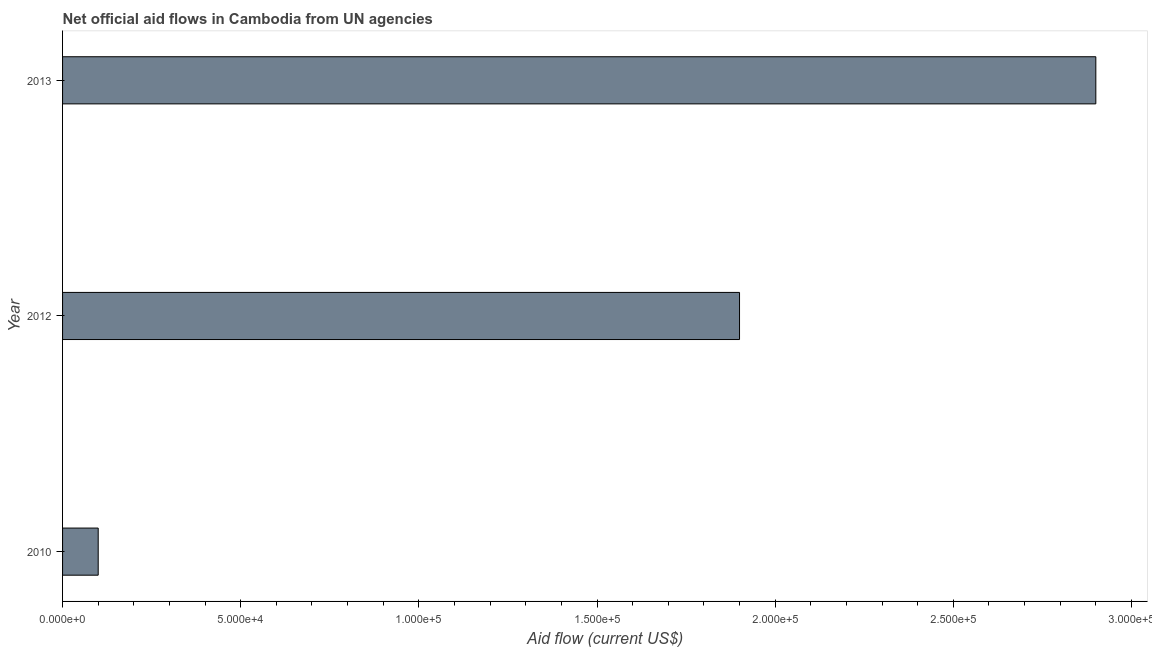Does the graph contain grids?
Make the answer very short. No. What is the title of the graph?
Provide a short and direct response. Net official aid flows in Cambodia from UN agencies. What is the label or title of the Y-axis?
Your response must be concise. Year. Across all years, what is the maximum net official flows from un agencies?
Your answer should be very brief. 2.90e+05. Across all years, what is the minimum net official flows from un agencies?
Your answer should be compact. 10000. In which year was the net official flows from un agencies maximum?
Your response must be concise. 2013. In which year was the net official flows from un agencies minimum?
Your answer should be very brief. 2010. What is the sum of the net official flows from un agencies?
Provide a succinct answer. 4.90e+05. What is the average net official flows from un agencies per year?
Offer a terse response. 1.63e+05. What is the ratio of the net official flows from un agencies in 2010 to that in 2012?
Your answer should be very brief. 0.05. Is the difference between the net official flows from un agencies in 2012 and 2013 greater than the difference between any two years?
Your response must be concise. No. Is the sum of the net official flows from un agencies in 2010 and 2012 greater than the maximum net official flows from un agencies across all years?
Give a very brief answer. No. What is the difference between the highest and the lowest net official flows from un agencies?
Give a very brief answer. 2.80e+05. In how many years, is the net official flows from un agencies greater than the average net official flows from un agencies taken over all years?
Provide a succinct answer. 2. How many bars are there?
Ensure brevity in your answer.  3. Are the values on the major ticks of X-axis written in scientific E-notation?
Offer a very short reply. Yes. What is the Aid flow (current US$) of 2010?
Your answer should be very brief. 10000. What is the Aid flow (current US$) of 2012?
Provide a succinct answer. 1.90e+05. What is the difference between the Aid flow (current US$) in 2010 and 2012?
Make the answer very short. -1.80e+05. What is the difference between the Aid flow (current US$) in 2010 and 2013?
Make the answer very short. -2.80e+05. What is the ratio of the Aid flow (current US$) in 2010 to that in 2012?
Offer a terse response. 0.05. What is the ratio of the Aid flow (current US$) in 2010 to that in 2013?
Offer a very short reply. 0.03. What is the ratio of the Aid flow (current US$) in 2012 to that in 2013?
Provide a short and direct response. 0.66. 